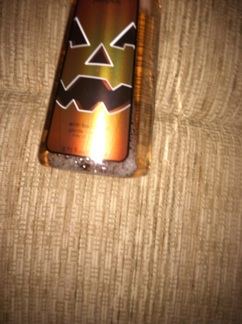What scent is this? The image shows a Halloween-themed spray can. While I can't determine the exact scent from just the image, products like these are often themed with seasonal scents such as pumpkin spice, cinnamon, or apple. Given the playful, spooky design, it might be a novelty scent designed for Halloween. 